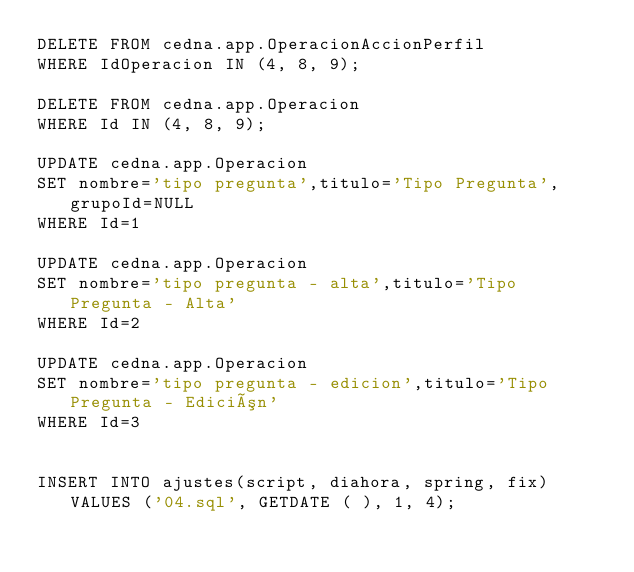Convert code to text. <code><loc_0><loc_0><loc_500><loc_500><_SQL_>DELETE FROM cedna.app.OperacionAccionPerfil
WHERE IdOperacion IN (4, 8, 9);

DELETE FROM cedna.app.Operacion
WHERE Id IN (4, 8, 9);

UPDATE cedna.app.Operacion
SET nombre='tipo pregunta',titulo='Tipo Pregunta',grupoId=NULL
WHERE Id=1 

UPDATE cedna.app.Operacion
SET nombre='tipo pregunta - alta',titulo='Tipo Pregunta - Alta'
WHERE Id=2 

UPDATE cedna.app.Operacion
SET nombre='tipo pregunta - edicion',titulo='Tipo Pregunta - Edición'
WHERE Id=3 


INSERT INTO ajustes(script, diahora, spring, fix) VALUES ('04.sql', GETDATE ( ), 1, 4);</code> 